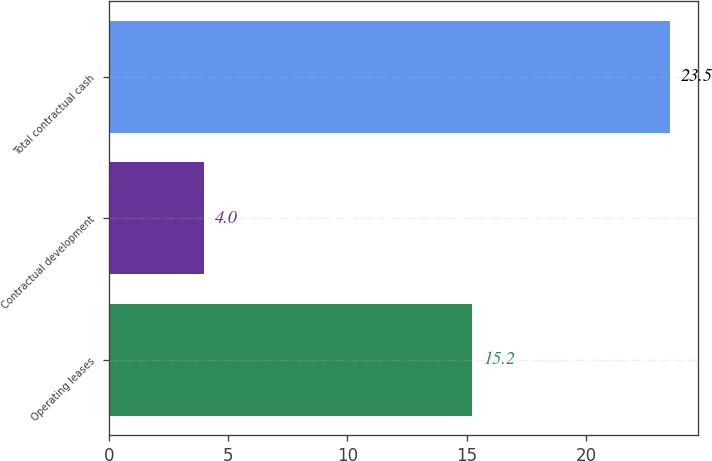<chart> <loc_0><loc_0><loc_500><loc_500><bar_chart><fcel>Operating leases<fcel>Contractual development<fcel>Total contractual cash<nl><fcel>15.2<fcel>4<fcel>23.5<nl></chart> 